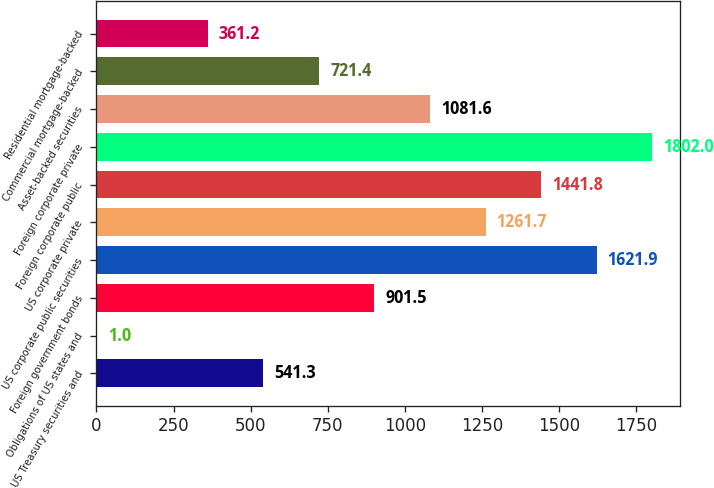Convert chart. <chart><loc_0><loc_0><loc_500><loc_500><bar_chart><fcel>US Treasury securities and<fcel>Obligations of US states and<fcel>Foreign government bonds<fcel>US corporate public securities<fcel>US corporate private<fcel>Foreign corporate public<fcel>Foreign corporate private<fcel>Asset-backed securities<fcel>Commercial mortgage-backed<fcel>Residential mortgage-backed<nl><fcel>541.3<fcel>1<fcel>901.5<fcel>1621.9<fcel>1261.7<fcel>1441.8<fcel>1802<fcel>1081.6<fcel>721.4<fcel>361.2<nl></chart> 